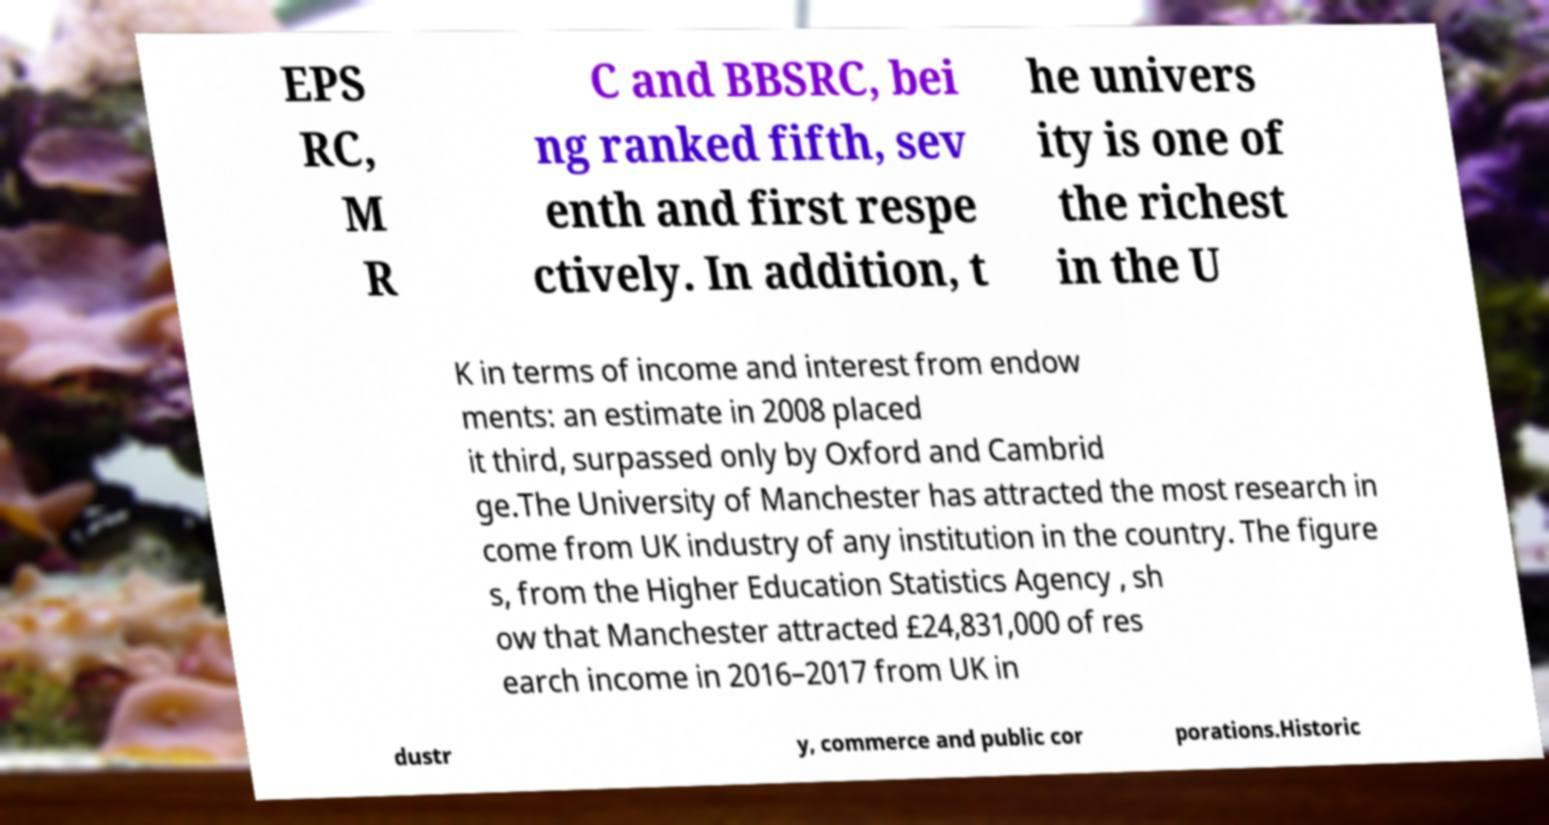Can you accurately transcribe the text from the provided image for me? EPS RC, M R C and BBSRC, bei ng ranked fifth, sev enth and first respe ctively. In addition, t he univers ity is one of the richest in the U K in terms of income and interest from endow ments: an estimate in 2008 placed it third, surpassed only by Oxford and Cambrid ge.The University of Manchester has attracted the most research in come from UK industry of any institution in the country. The figure s, from the Higher Education Statistics Agency , sh ow that Manchester attracted £24,831,000 of res earch income in 2016–2017 from UK in dustr y, commerce and public cor porations.Historic 